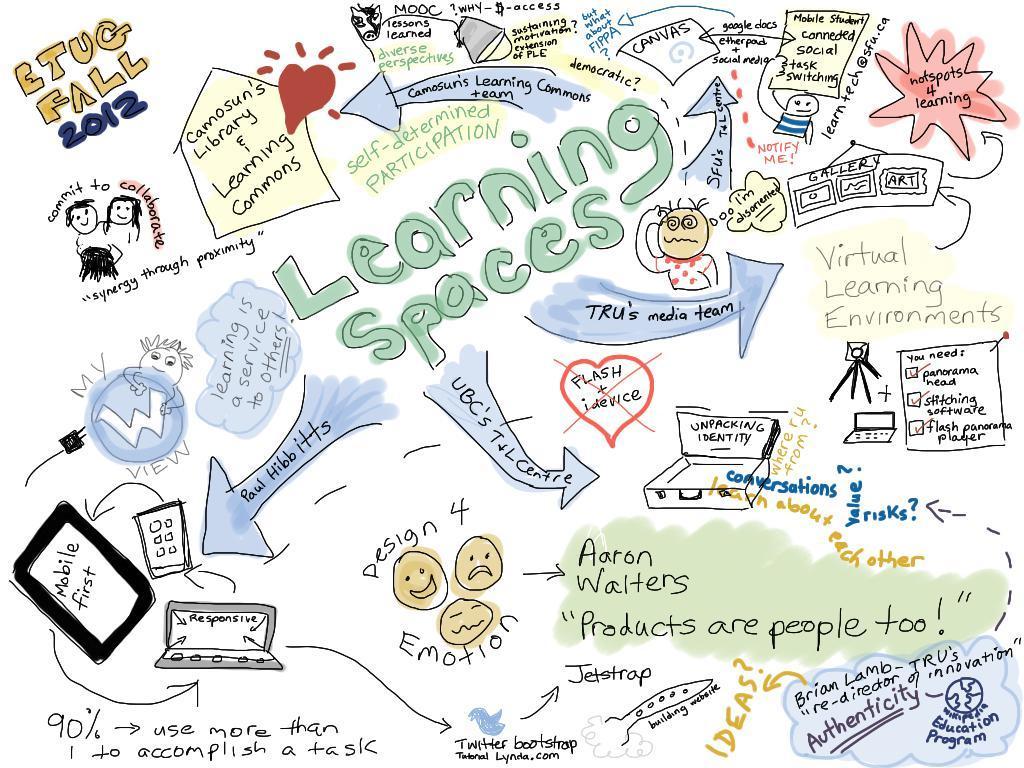Please provide a concise description of this image. In this image we can see an edited image, in which we can see some pictures and some text. 